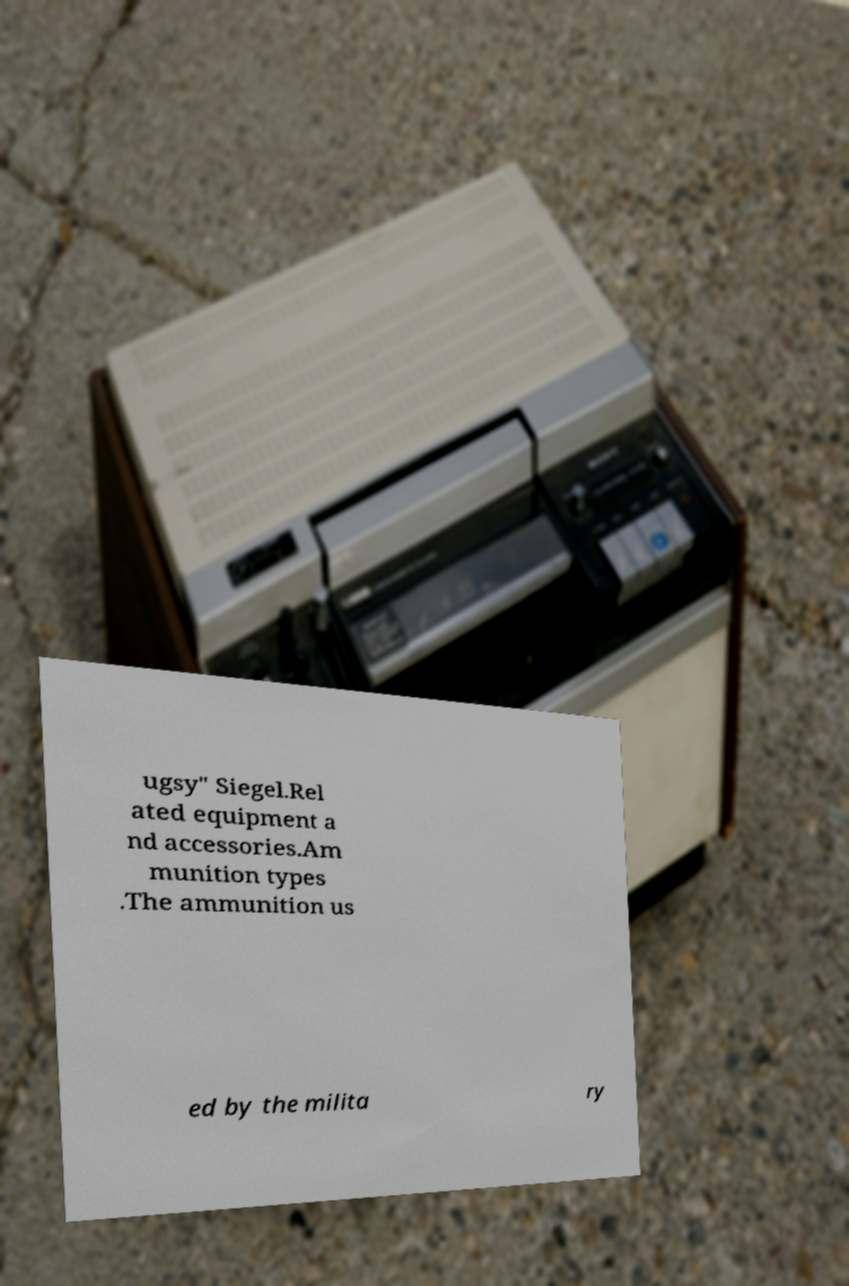There's text embedded in this image that I need extracted. Can you transcribe it verbatim? ugsy" Siegel.Rel ated equipment a nd accessories.Am munition types .The ammunition us ed by the milita ry 